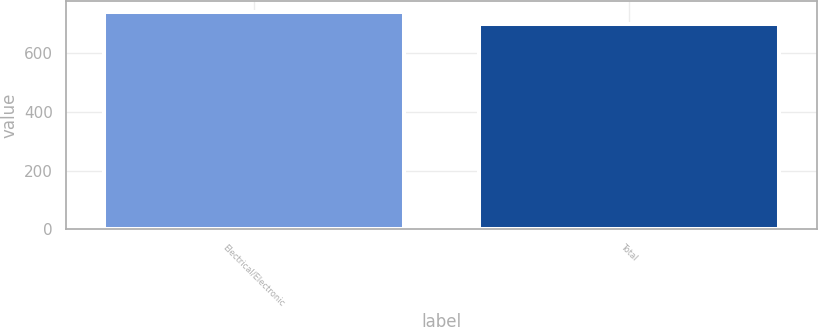Convert chart to OTSL. <chart><loc_0><loc_0><loc_500><loc_500><bar_chart><fcel>Electrical/Electronic<fcel>Total<nl><fcel>742<fcel>701<nl></chart> 